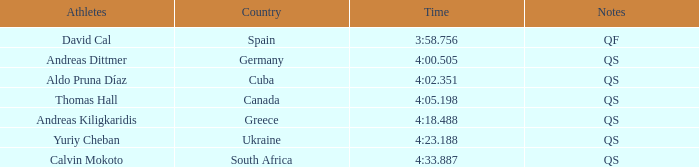What are the remarks for the competitor from south africa? QS. 